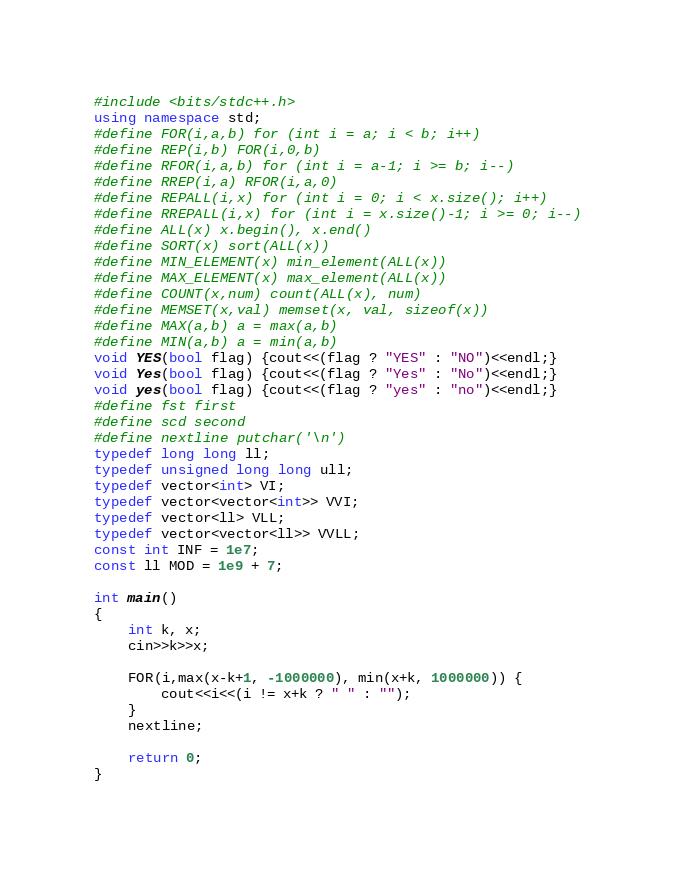<code> <loc_0><loc_0><loc_500><loc_500><_C++_>#include <bits/stdc++.h>
using namespace std;
#define FOR(i,a,b) for (int i = a; i < b; i++)
#define REP(i,b) FOR(i,0,b)
#define RFOR(i,a,b) for (int i = a-1; i >= b; i--)
#define RREP(i,a) RFOR(i,a,0)
#define REPALL(i,x) for (int i = 0; i < x.size(); i++)
#define RREPALL(i,x) for (int i = x.size()-1; i >= 0; i--)
#define ALL(x) x.begin(), x.end()
#define SORT(x) sort(ALL(x))
#define MIN_ELEMENT(x) min_element(ALL(x))
#define MAX_ELEMENT(x) max_element(ALL(x))
#define COUNT(x,num) count(ALL(x), num)
#define MEMSET(x,val) memset(x, val, sizeof(x))
#define MAX(a,b) a = max(a,b)
#define MIN(a,b) a = min(a,b)
void YES(bool flag) {cout<<(flag ? "YES" : "NO")<<endl;}
void Yes(bool flag) {cout<<(flag ? "Yes" : "No")<<endl;}
void yes(bool flag) {cout<<(flag ? "yes" : "no")<<endl;}
#define fst first
#define scd second
#define nextline putchar('\n')
typedef long long ll;
typedef unsigned long long ull;
typedef vector<int> VI;
typedef vector<vector<int>> VVI;
typedef vector<ll> VLL;
typedef vector<vector<ll>> VVLL;
const int INF = 1e7;
const ll MOD = 1e9 + 7;

int main()
{
    int k, x;
    cin>>k>>x;

    FOR(i,max(x-k+1, -1000000), min(x+k, 1000000)) {
        cout<<i<<(i != x+k ? " " : "");
    }
    nextline;

    return 0;
}
</code> 